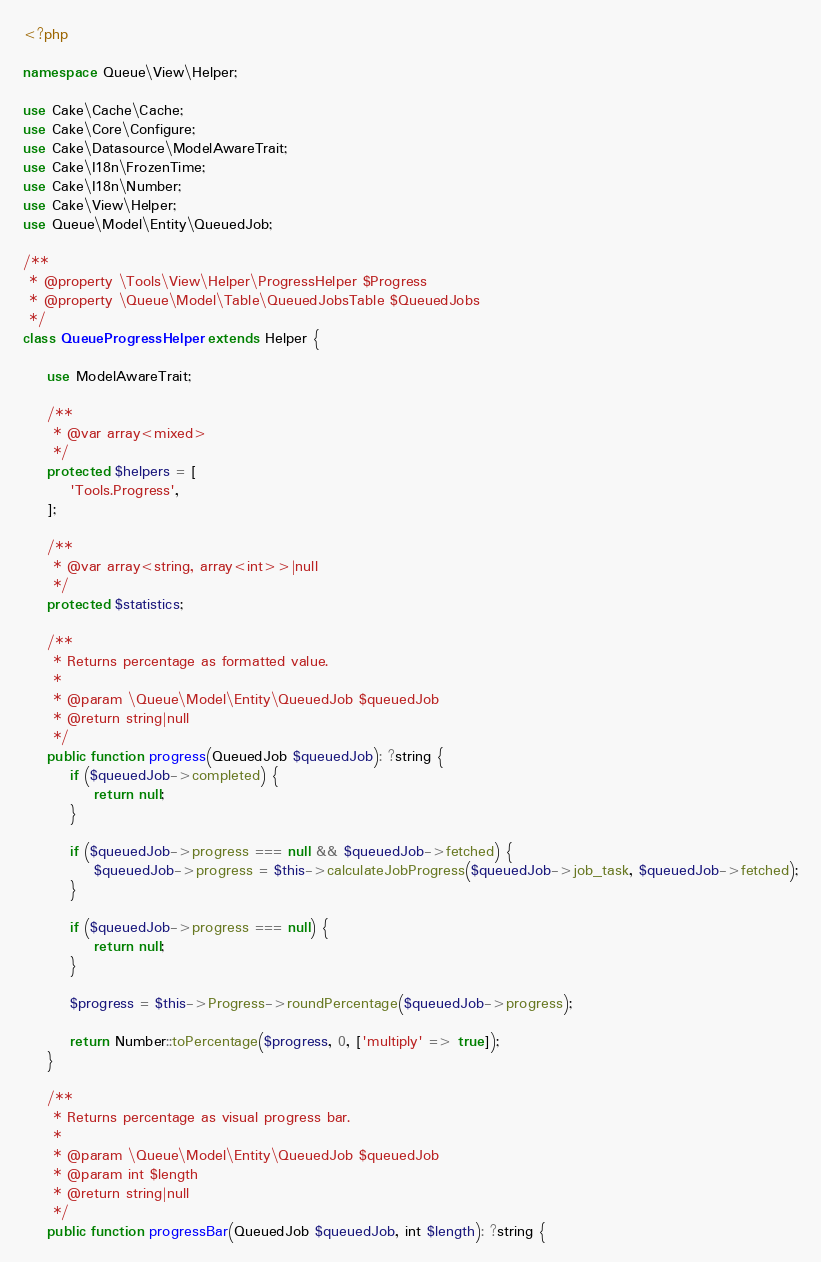<code> <loc_0><loc_0><loc_500><loc_500><_PHP_><?php

namespace Queue\View\Helper;

use Cake\Cache\Cache;
use Cake\Core\Configure;
use Cake\Datasource\ModelAwareTrait;
use Cake\I18n\FrozenTime;
use Cake\I18n\Number;
use Cake\View\Helper;
use Queue\Model\Entity\QueuedJob;

/**
 * @property \Tools\View\Helper\ProgressHelper $Progress
 * @property \Queue\Model\Table\QueuedJobsTable $QueuedJobs
 */
class QueueProgressHelper extends Helper {

	use ModelAwareTrait;

	/**
	 * @var array<mixed>
	 */
	protected $helpers = [
		'Tools.Progress',
	];

	/**
	 * @var array<string, array<int>>|null
	 */
	protected $statistics;

	/**
	 * Returns percentage as formatted value.
	 *
	 * @param \Queue\Model\Entity\QueuedJob $queuedJob
	 * @return string|null
	 */
	public function progress(QueuedJob $queuedJob): ?string {
		if ($queuedJob->completed) {
			return null;
		}

		if ($queuedJob->progress === null && $queuedJob->fetched) {
			$queuedJob->progress = $this->calculateJobProgress($queuedJob->job_task, $queuedJob->fetched);
		}

		if ($queuedJob->progress === null) {
			return null;
		}

		$progress = $this->Progress->roundPercentage($queuedJob->progress);

		return Number::toPercentage($progress, 0, ['multiply' => true]);
	}

	/**
	 * Returns percentage as visual progress bar.
	 *
	 * @param \Queue\Model\Entity\QueuedJob $queuedJob
	 * @param int $length
	 * @return string|null
	 */
	public function progressBar(QueuedJob $queuedJob, int $length): ?string {</code> 